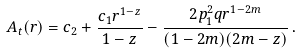<formula> <loc_0><loc_0><loc_500><loc_500>A _ { t } ( r ) = c _ { 2 } + \frac { c _ { 1 } r ^ { 1 - z } } { 1 - z } - \frac { 2 p _ { 1 } ^ { 2 } q r ^ { 1 - 2 m } } { ( 1 - 2 m ) ( 2 m - z ) } \, .</formula> 